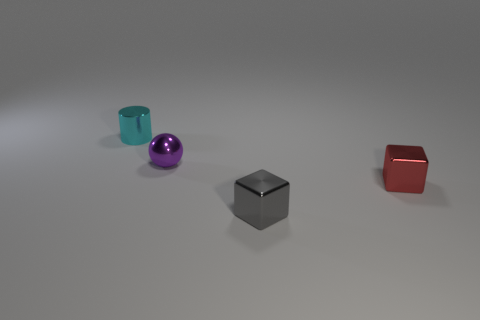If we were to use these objects in a storytelling context, what characters or roles could they represent? In a storytelling context, the brightly-colored, shiny sphere might represent an energetic, bubbly character, the sturdy matte cube could be seen as a reliable, strong figure, and the red cube could symbolize a character with a bold, perhaps fiery personality. 